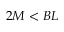<formula> <loc_0><loc_0><loc_500><loc_500>2 M < B L</formula> 